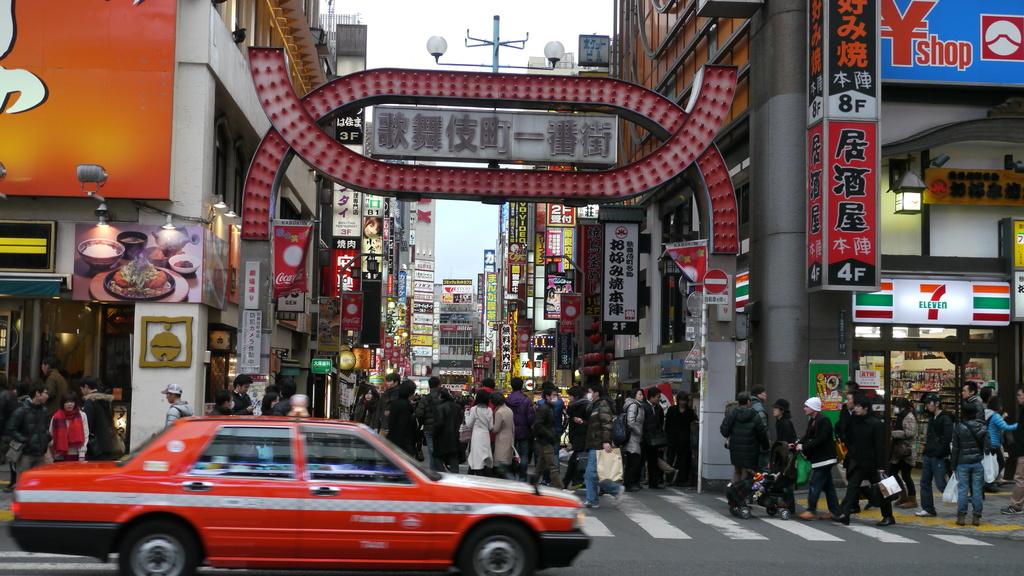What color is the main car?
Provide a short and direct response. Red. 